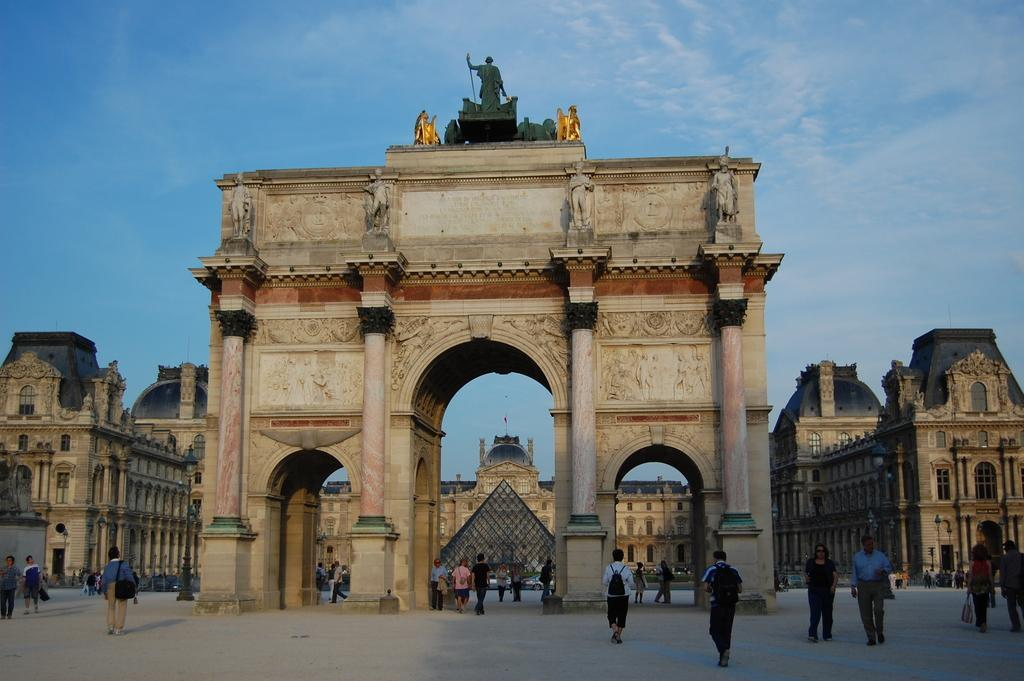What type of structures can be seen in the image? There are buildings in the image. Are there any decorative elements on the buildings? Yes, there are statues on the buildings. What is happening on the ground in the image? There are people on the ground. What are some of the people doing? Some people are carrying bags. What can be seen in the background of the image? The sky is visible in the background. Can you tell me where the key is located in the image? There is no key present in the image. Is there a family depicted in the image? The provided facts do not mention a family, so we cannot determine if one is present in the image. 